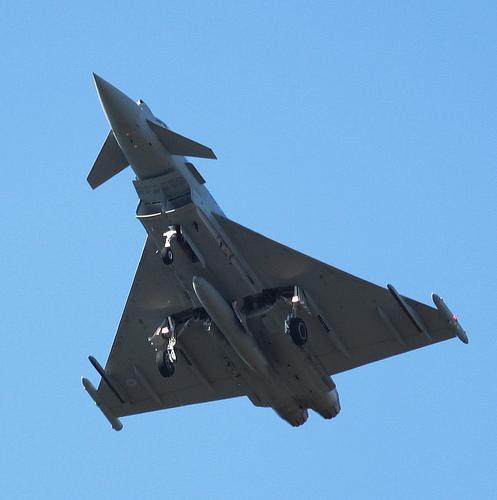How many planes are seen?
Give a very brief answer. 1. 